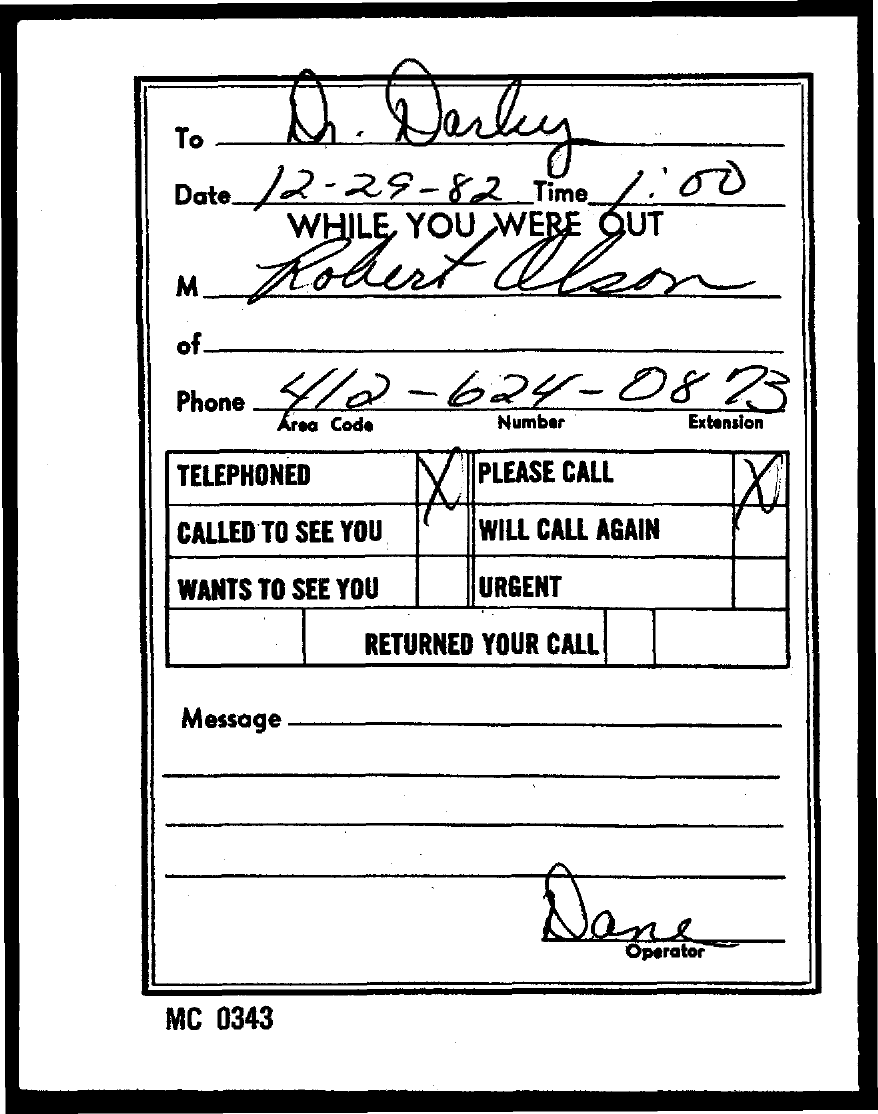To Whom is this letter addressed to?
Provide a short and direct response. Dr. Darby. What is the Date?
Provide a succinct answer. 12-29-82. What is the Time?
Your response must be concise. 1:00. What is the Phone?
Your response must be concise. 412-624-0873. Who is the operator?
Offer a very short reply. Dane. 